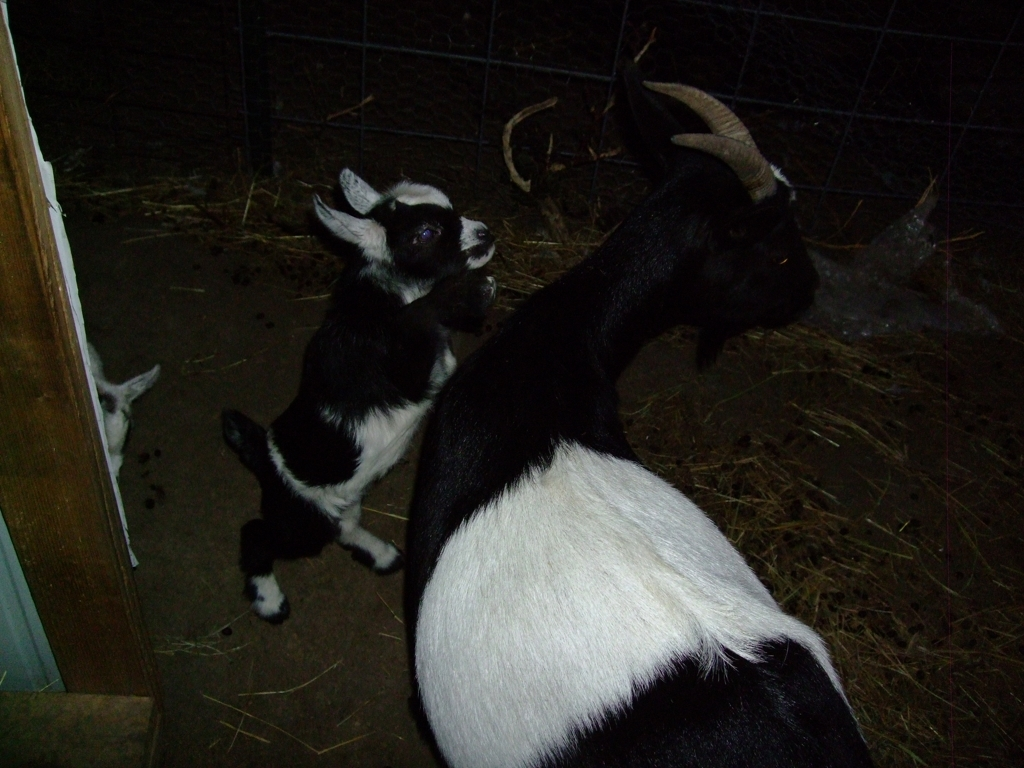Can you tell me what kind of animals are in this photo? Sure, the photo depicts goats. The larger one with prominent horns appears to be an adult goat, likely a breed known for having distinct black and white patterns on its body. The smaller one is a young goat, also known as a kid, identifiable by its small size and less developed horns. What are they doing in the picture? It looks like the kid goat is reaching up towards something outside the frame, possibly interacting with a person or trying to reach for food. The adult goat seems to be standing guard or supervising the kid, a common behavior seen in herd animals. 